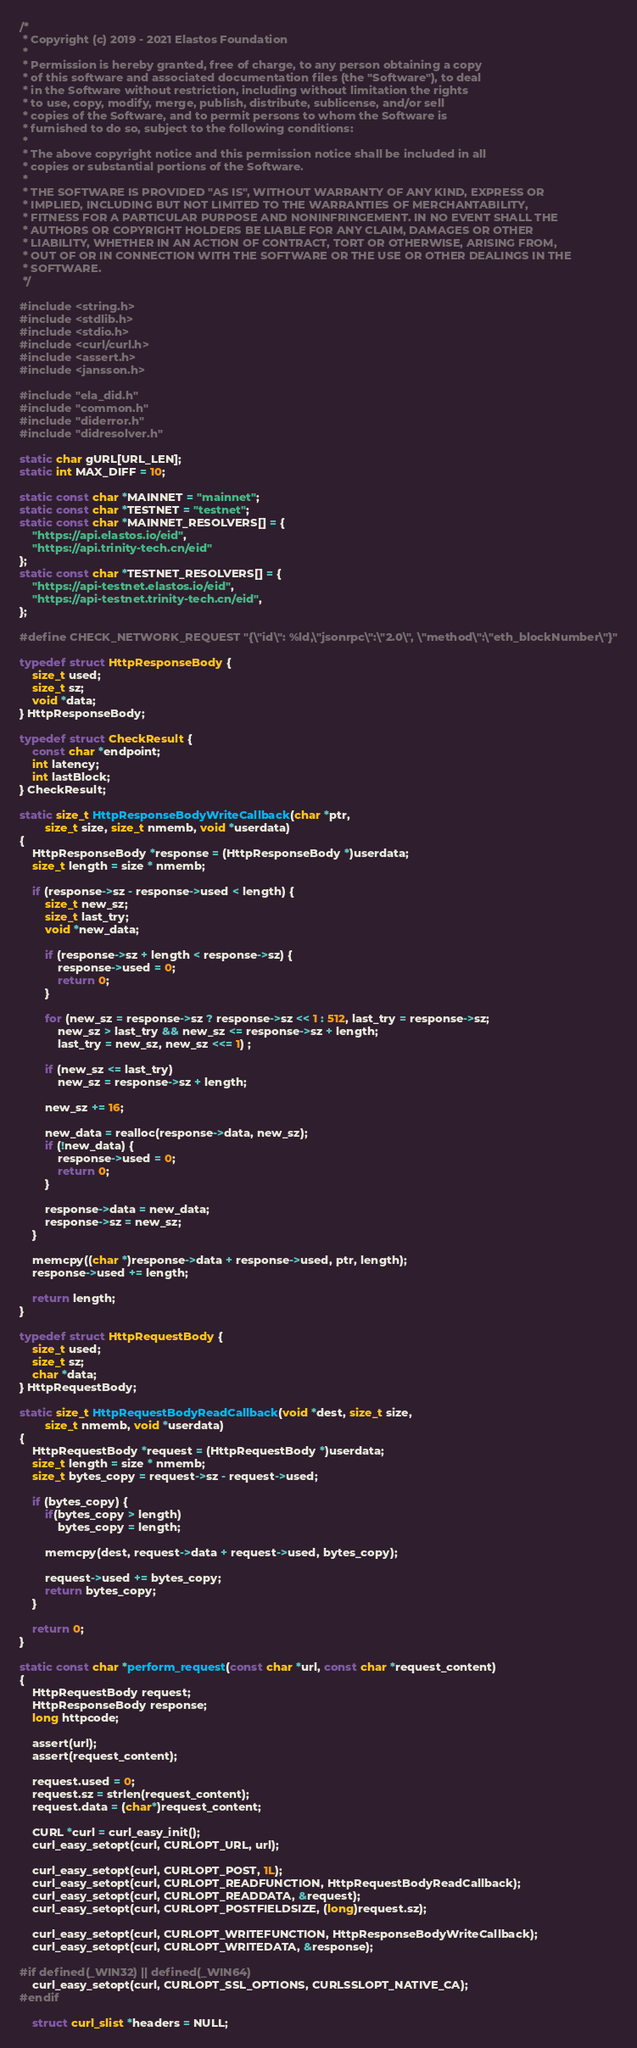Convert code to text. <code><loc_0><loc_0><loc_500><loc_500><_C_>/*
 * Copyright (c) 2019 - 2021 Elastos Foundation
 *
 * Permission is hereby granted, free of charge, to any person obtaining a copy
 * of this software and associated documentation files (the "Software"), to deal
 * in the Software without restriction, including without limitation the rights
 * to use, copy, modify, merge, publish, distribute, sublicense, and/or sell
 * copies of the Software, and to permit persons to whom the Software is
 * furnished to do so, subject to the following conditions:
 *
 * The above copyright notice and this permission notice shall be included in all
 * copies or substantial portions of the Software.
 *
 * THE SOFTWARE IS PROVIDED "AS IS", WITHOUT WARRANTY OF ANY KIND, EXPRESS OR
 * IMPLIED, INCLUDING BUT NOT LIMITED TO THE WARRANTIES OF MERCHANTABILITY,
 * FITNESS FOR A PARTICULAR PURPOSE AND NONINFRINGEMENT. IN NO EVENT SHALL THE
 * AUTHORS OR COPYRIGHT HOLDERS BE LIABLE FOR ANY CLAIM, DAMAGES OR OTHER
 * LIABILITY, WHETHER IN AN ACTION OF CONTRACT, TORT OR OTHERWISE, ARISING FROM,
 * OUT OF OR IN CONNECTION WITH THE SOFTWARE OR THE USE OR OTHER DEALINGS IN THE
 * SOFTWARE.
 */

#include <string.h>
#include <stdlib.h>
#include <stdio.h>
#include <curl/curl.h>
#include <assert.h>
#include <jansson.h>

#include "ela_did.h"
#include "common.h"
#include "diderror.h"
#include "didresolver.h"

static char gURL[URL_LEN];
static int MAX_DIFF = 10;

static const char *MAINNET = "mainnet";
static const char *TESTNET = "testnet";
static const char *MAINNET_RESOLVERS[] = {
    "https://api.elastos.io/eid",
    "https://api.trinity-tech.cn/eid"
};
static const char *TESTNET_RESOLVERS[] = {
    "https://api-testnet.elastos.io/eid",
    "https://api-testnet.trinity-tech.cn/eid",
};

#define CHECK_NETWORK_REQUEST "{\"id\": %ld,\"jsonrpc\":\"2.0\", \"method\":\"eth_blockNumber\"}"

typedef struct HttpResponseBody {
    size_t used;
    size_t sz;
    void *data;
} HttpResponseBody;

typedef struct CheckResult {
    const char *endpoint;
    int latency;
    int lastBlock;
} CheckResult;

static size_t HttpResponseBodyWriteCallback(char *ptr,
        size_t size, size_t nmemb, void *userdata)
{
    HttpResponseBody *response = (HttpResponseBody *)userdata;
    size_t length = size * nmemb;

    if (response->sz - response->used < length) {
        size_t new_sz;
        size_t last_try;
        void *new_data;

        if (response->sz + length < response->sz) {
            response->used = 0;
            return 0;
        }

        for (new_sz = response->sz ? response->sz << 1 : 512, last_try = response->sz;
            new_sz > last_try && new_sz <= response->sz + length;
            last_try = new_sz, new_sz <<= 1) ;

        if (new_sz <= last_try)
            new_sz = response->sz + length;

        new_sz += 16;

        new_data = realloc(response->data, new_sz);
        if (!new_data) {
            response->used = 0;
            return 0;
        }

        response->data = new_data;
        response->sz = new_sz;
    }

    memcpy((char *)response->data + response->used, ptr, length);
    response->used += length;

    return length;
}

typedef struct HttpRequestBody {
    size_t used;
    size_t sz;
    char *data;
} HttpRequestBody;

static size_t HttpRequestBodyReadCallback(void *dest, size_t size,
        size_t nmemb, void *userdata)
{
    HttpRequestBody *request = (HttpRequestBody *)userdata;
    size_t length = size * nmemb;
    size_t bytes_copy = request->sz - request->used;

    if (bytes_copy) {
        if(bytes_copy > length)
            bytes_copy = length;

        memcpy(dest, request->data + request->used, bytes_copy);

        request->used += bytes_copy;
        return bytes_copy;
    }

    return 0;
}

static const char *perform_request(const char *url, const char *request_content)
{
    HttpRequestBody request;
    HttpResponseBody response;
    long httpcode;

    assert(url);
    assert(request_content);

    request.used = 0;
    request.sz = strlen(request_content);
    request.data = (char*)request_content;

    CURL *curl = curl_easy_init();
    curl_easy_setopt(curl, CURLOPT_URL, url);

    curl_easy_setopt(curl, CURLOPT_POST, 1L);
    curl_easy_setopt(curl, CURLOPT_READFUNCTION, HttpRequestBodyReadCallback);
    curl_easy_setopt(curl, CURLOPT_READDATA, &request);
    curl_easy_setopt(curl, CURLOPT_POSTFIELDSIZE, (long)request.sz);

    curl_easy_setopt(curl, CURLOPT_WRITEFUNCTION, HttpResponseBodyWriteCallback);
    curl_easy_setopt(curl, CURLOPT_WRITEDATA, &response);

#if defined(_WIN32) || defined(_WIN64)
    curl_easy_setopt(curl, CURLOPT_SSL_OPTIONS, CURLSSLOPT_NATIVE_CA);
#endif

    struct curl_slist *headers = NULL;</code> 